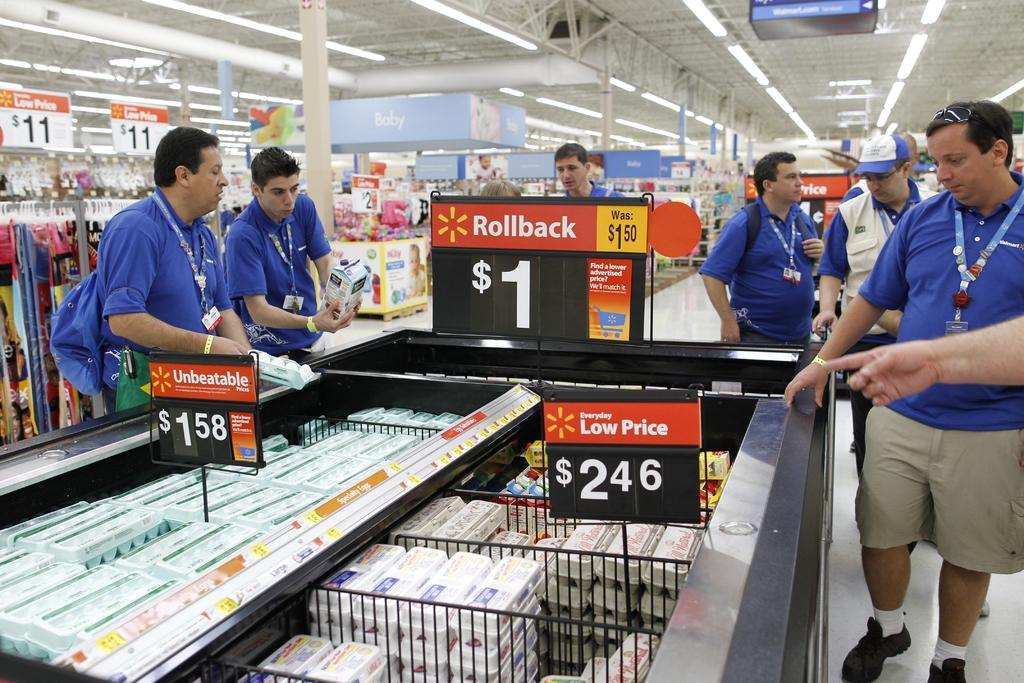<image>
Create a compact narrative representing the image presented. Four Walmart employees near a Rollback $1 sign. 